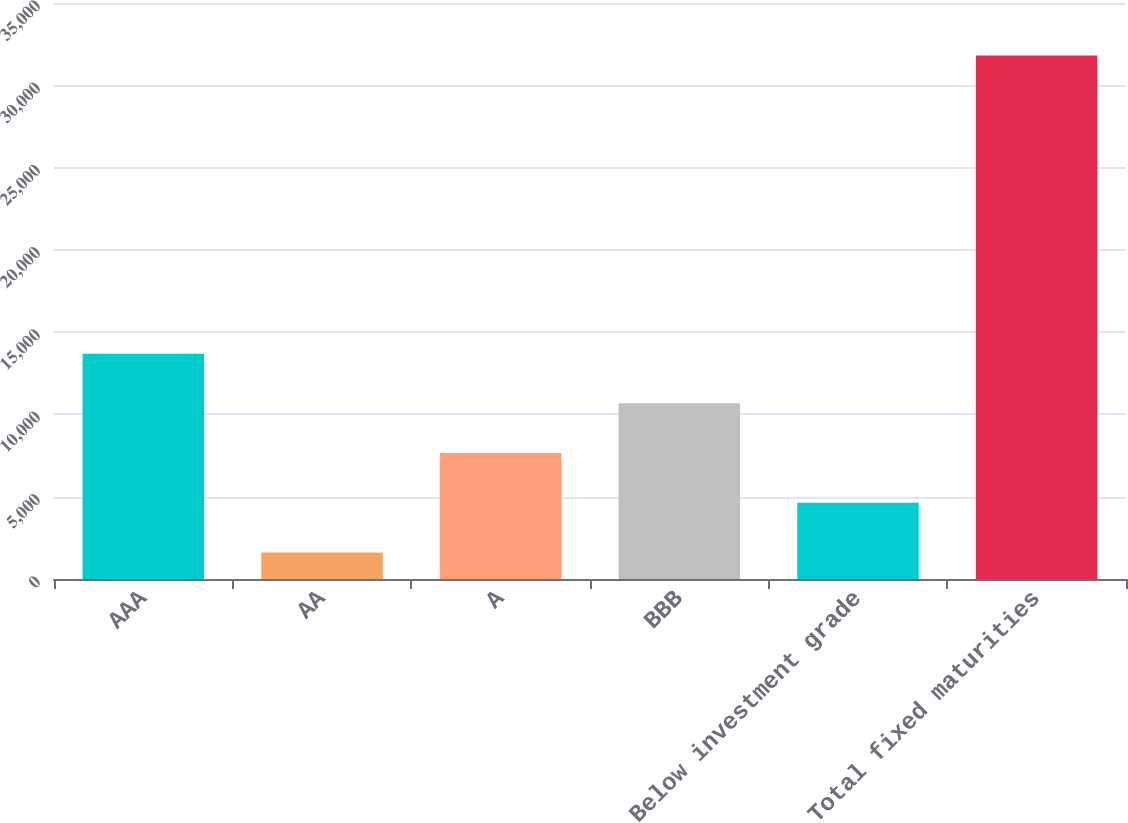<chart> <loc_0><loc_0><loc_500><loc_500><bar_chart><fcel>AAA<fcel>AA<fcel>A<fcel>BBB<fcel>Below investment grade<fcel>Total fixed maturities<nl><fcel>13692.8<fcel>1616<fcel>7654.4<fcel>10673.6<fcel>4635.2<fcel>31808<nl></chart> 